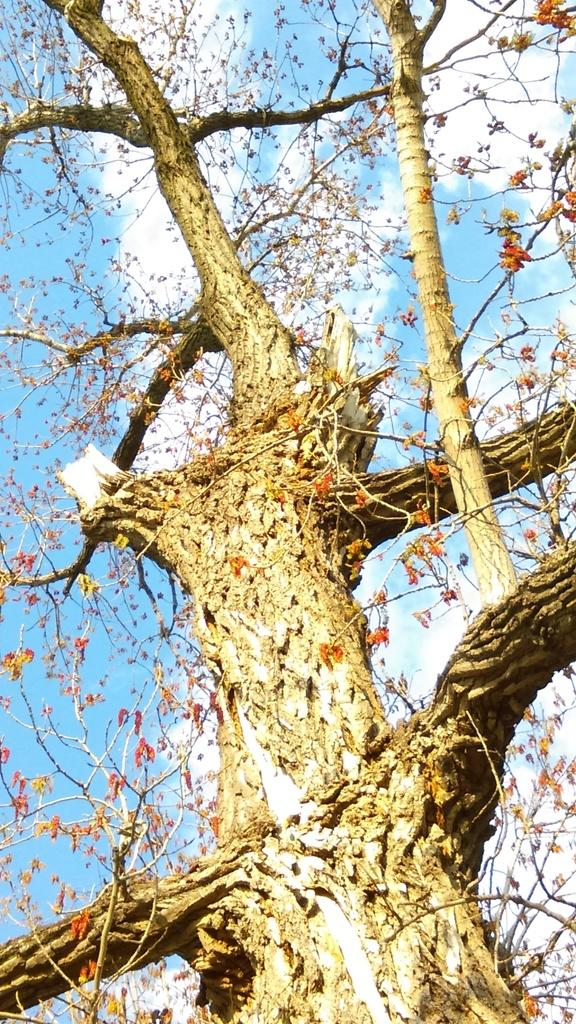What type of plant can be seen in the image? There is a tree in the image. What other natural elements can be seen in the image? There are flowers in the image. What is visible in the background of the image? The sky is visible in the background of the image. What can be observed in the sky? Clouds are present in the sky. What type of organization does the beginner in the image belong to? There is no person or organization mentioned in the image, so it is not possible to answer this question. 